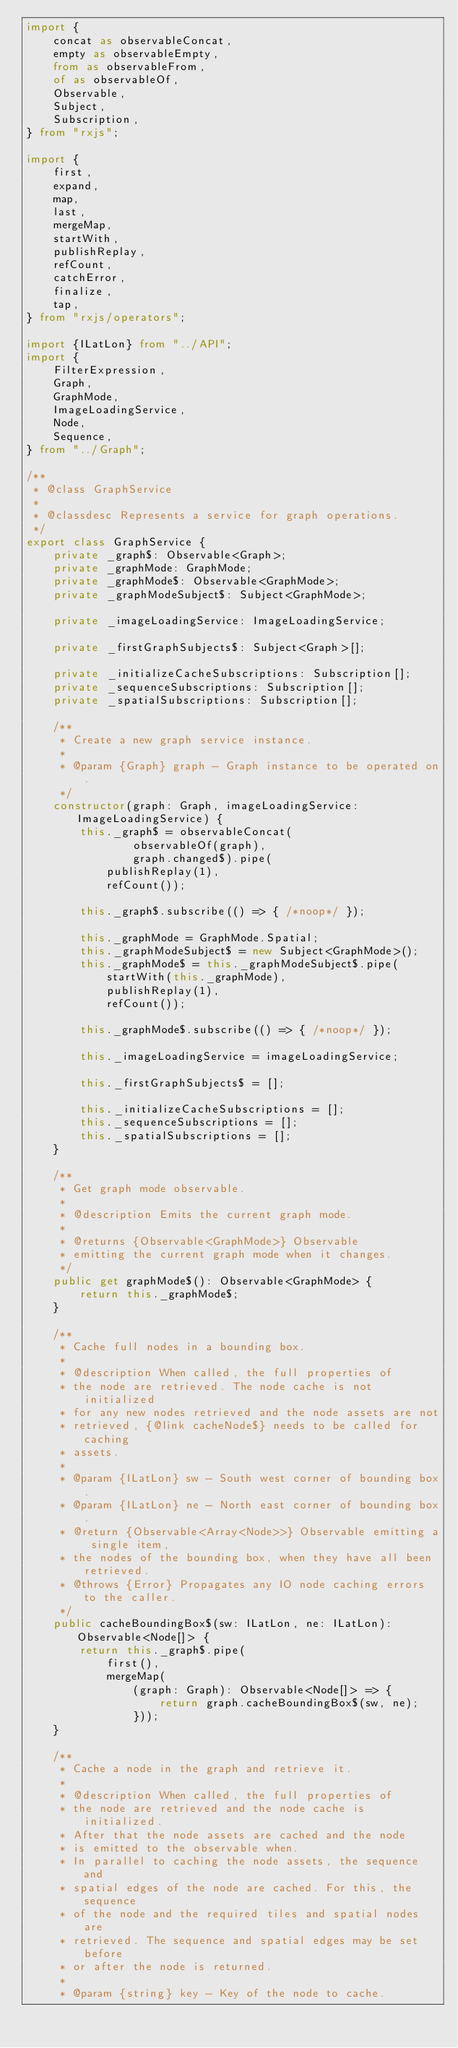<code> <loc_0><loc_0><loc_500><loc_500><_TypeScript_>import {
    concat as observableConcat,
    empty as observableEmpty,
    from as observableFrom,
    of as observableOf,
    Observable,
    Subject,
    Subscription,
} from "rxjs";

import {
    first,
    expand,
    map,
    last,
    mergeMap,
    startWith,
    publishReplay,
    refCount,
    catchError,
    finalize,
    tap,
} from "rxjs/operators";

import {ILatLon} from "../API";
import {
    FilterExpression,
    Graph,
    GraphMode,
    ImageLoadingService,
    Node,
    Sequence,
} from "../Graph";

/**
 * @class GraphService
 *
 * @classdesc Represents a service for graph operations.
 */
export class GraphService {
    private _graph$: Observable<Graph>;
    private _graphMode: GraphMode;
    private _graphMode$: Observable<GraphMode>;
    private _graphModeSubject$: Subject<GraphMode>;

    private _imageLoadingService: ImageLoadingService;

    private _firstGraphSubjects$: Subject<Graph>[];

    private _initializeCacheSubscriptions: Subscription[];
    private _sequenceSubscriptions: Subscription[];
    private _spatialSubscriptions: Subscription[];

    /**
     * Create a new graph service instance.
     *
     * @param {Graph} graph - Graph instance to be operated on.
     */
    constructor(graph: Graph, imageLoadingService: ImageLoadingService) {
        this._graph$ = observableConcat(
                observableOf(graph),
                graph.changed$).pipe(
            publishReplay(1),
            refCount());

        this._graph$.subscribe(() => { /*noop*/ });

        this._graphMode = GraphMode.Spatial;
        this._graphModeSubject$ = new Subject<GraphMode>();
        this._graphMode$ = this._graphModeSubject$.pipe(
            startWith(this._graphMode),
            publishReplay(1),
            refCount());

        this._graphMode$.subscribe(() => { /*noop*/ });

        this._imageLoadingService = imageLoadingService;

        this._firstGraphSubjects$ = [];

        this._initializeCacheSubscriptions = [];
        this._sequenceSubscriptions = [];
        this._spatialSubscriptions = [];
    }

    /**
     * Get graph mode observable.
     *
     * @description Emits the current graph mode.
     *
     * @returns {Observable<GraphMode>} Observable
     * emitting the current graph mode when it changes.
     */
    public get graphMode$(): Observable<GraphMode> {
        return this._graphMode$;
    }

    /**
     * Cache full nodes in a bounding box.
     *
     * @description When called, the full properties of
     * the node are retrieved. The node cache is not initialized
     * for any new nodes retrieved and the node assets are not
     * retrieved, {@link cacheNode$} needs to be called for caching
     * assets.
     *
     * @param {ILatLon} sw - South west corner of bounding box.
     * @param {ILatLon} ne - North east corner of bounding box.
     * @return {Observable<Array<Node>>} Observable emitting a single item,
     * the nodes of the bounding box, when they have all been retrieved.
     * @throws {Error} Propagates any IO node caching errors to the caller.
     */
    public cacheBoundingBox$(sw: ILatLon, ne: ILatLon): Observable<Node[]> {
        return this._graph$.pipe(
            first(),
            mergeMap(
                (graph: Graph): Observable<Node[]> => {
                    return graph.cacheBoundingBox$(sw, ne);
                }));
    }

    /**
     * Cache a node in the graph and retrieve it.
     *
     * @description When called, the full properties of
     * the node are retrieved and the node cache is initialized.
     * After that the node assets are cached and the node
     * is emitted to the observable when.
     * In parallel to caching the node assets, the sequence and
     * spatial edges of the node are cached. For this, the sequence
     * of the node and the required tiles and spatial nodes are
     * retrieved. The sequence and spatial edges may be set before
     * or after the node is returned.
     *
     * @param {string} key - Key of the node to cache.</code> 